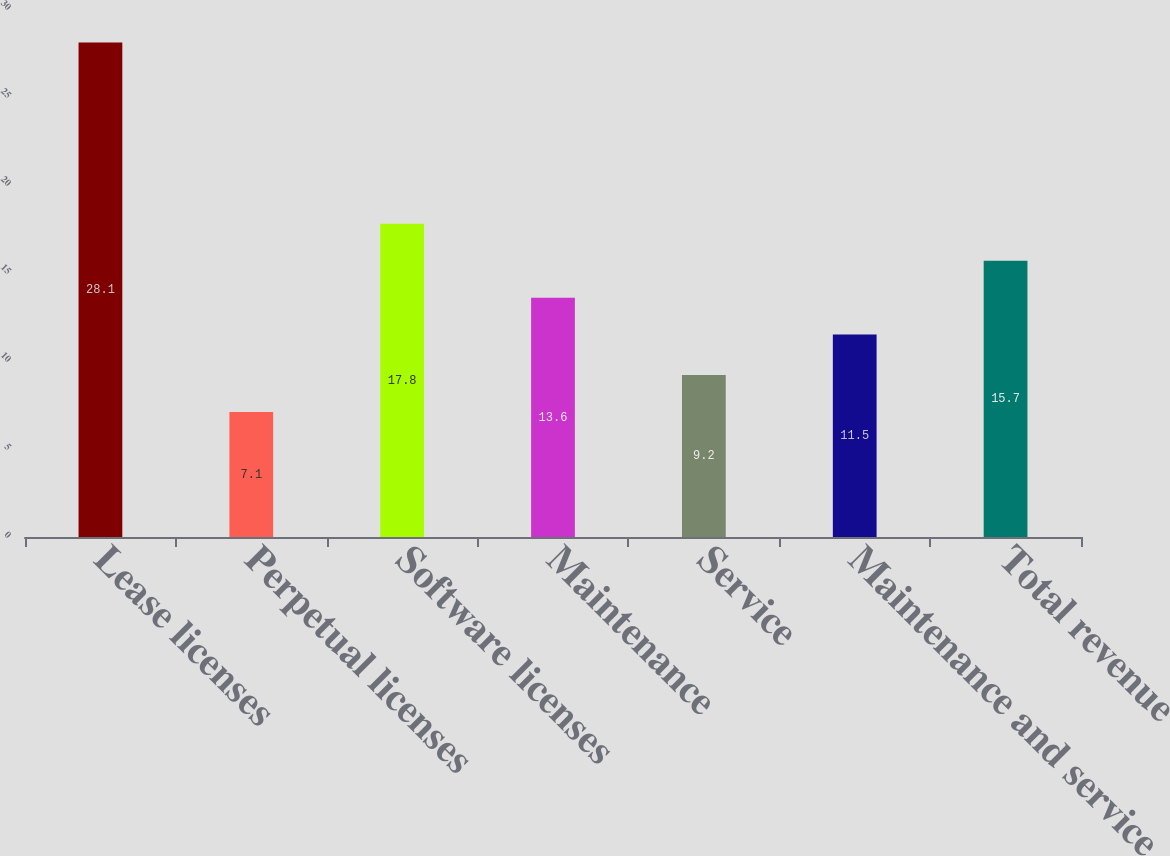Convert chart to OTSL. <chart><loc_0><loc_0><loc_500><loc_500><bar_chart><fcel>Lease licenses<fcel>Perpetual licenses<fcel>Software licenses<fcel>Maintenance<fcel>Service<fcel>Maintenance and service<fcel>Total revenue<nl><fcel>28.1<fcel>7.1<fcel>17.8<fcel>13.6<fcel>9.2<fcel>11.5<fcel>15.7<nl></chart> 